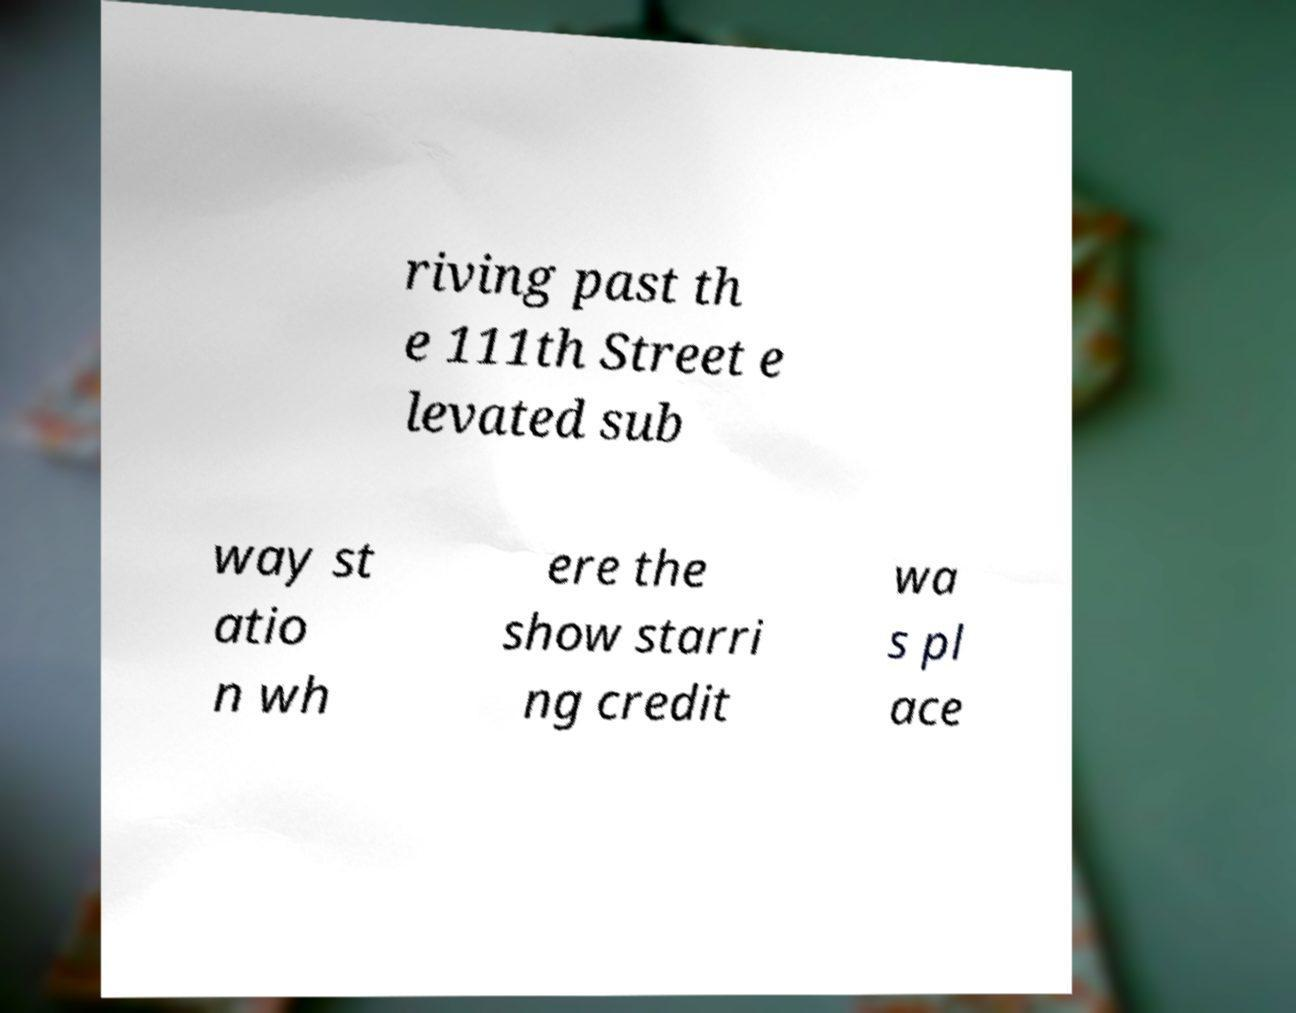Please read and relay the text visible in this image. What does it say? riving past th e 111th Street e levated sub way st atio n wh ere the show starri ng credit wa s pl ace 